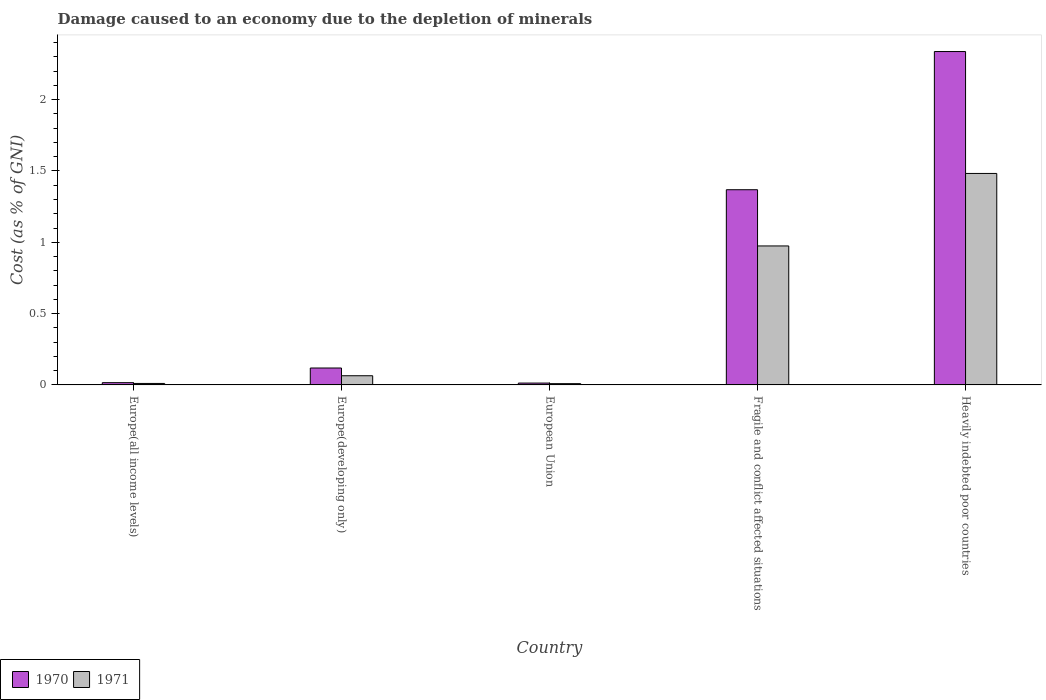How many different coloured bars are there?
Offer a very short reply. 2. How many groups of bars are there?
Make the answer very short. 5. Are the number of bars per tick equal to the number of legend labels?
Give a very brief answer. Yes. Are the number of bars on each tick of the X-axis equal?
Your answer should be very brief. Yes. What is the label of the 4th group of bars from the left?
Keep it short and to the point. Fragile and conflict affected situations. In how many cases, is the number of bars for a given country not equal to the number of legend labels?
Ensure brevity in your answer.  0. What is the cost of damage caused due to the depletion of minerals in 1971 in Europe(all income levels)?
Your answer should be very brief. 0.01. Across all countries, what is the maximum cost of damage caused due to the depletion of minerals in 1971?
Your answer should be very brief. 1.48. Across all countries, what is the minimum cost of damage caused due to the depletion of minerals in 1971?
Provide a succinct answer. 0.01. In which country was the cost of damage caused due to the depletion of minerals in 1971 maximum?
Offer a very short reply. Heavily indebted poor countries. What is the total cost of damage caused due to the depletion of minerals in 1971 in the graph?
Keep it short and to the point. 2.54. What is the difference between the cost of damage caused due to the depletion of minerals in 1971 in Europe(all income levels) and that in Fragile and conflict affected situations?
Provide a short and direct response. -0.96. What is the difference between the cost of damage caused due to the depletion of minerals in 1971 in Fragile and conflict affected situations and the cost of damage caused due to the depletion of minerals in 1970 in Europe(all income levels)?
Your answer should be very brief. 0.96. What is the average cost of damage caused due to the depletion of minerals in 1970 per country?
Give a very brief answer. 0.77. What is the difference between the cost of damage caused due to the depletion of minerals of/in 1971 and cost of damage caused due to the depletion of minerals of/in 1970 in Europe(developing only)?
Ensure brevity in your answer.  -0.05. In how many countries, is the cost of damage caused due to the depletion of minerals in 1971 greater than 1.9 %?
Ensure brevity in your answer.  0. What is the ratio of the cost of damage caused due to the depletion of minerals in 1971 in Europe(developing only) to that in Fragile and conflict affected situations?
Make the answer very short. 0.07. Is the cost of damage caused due to the depletion of minerals in 1971 in Europe(all income levels) less than that in Europe(developing only)?
Offer a very short reply. Yes. What is the difference between the highest and the second highest cost of damage caused due to the depletion of minerals in 1971?
Give a very brief answer. -0.51. What is the difference between the highest and the lowest cost of damage caused due to the depletion of minerals in 1971?
Your answer should be compact. 1.47. How many bars are there?
Give a very brief answer. 10. How many countries are there in the graph?
Your answer should be compact. 5. What is the difference between two consecutive major ticks on the Y-axis?
Offer a very short reply. 0.5. Does the graph contain any zero values?
Give a very brief answer. No. Does the graph contain grids?
Your answer should be very brief. No. Where does the legend appear in the graph?
Give a very brief answer. Bottom left. How are the legend labels stacked?
Give a very brief answer. Horizontal. What is the title of the graph?
Offer a very short reply. Damage caused to an economy due to the depletion of minerals. What is the label or title of the Y-axis?
Keep it short and to the point. Cost (as % of GNI). What is the Cost (as % of GNI) of 1970 in Europe(all income levels)?
Offer a very short reply. 0.02. What is the Cost (as % of GNI) of 1971 in Europe(all income levels)?
Provide a succinct answer. 0.01. What is the Cost (as % of GNI) in 1970 in Europe(developing only)?
Offer a very short reply. 0.12. What is the Cost (as % of GNI) in 1971 in Europe(developing only)?
Your answer should be compact. 0.06. What is the Cost (as % of GNI) of 1970 in European Union?
Your answer should be compact. 0.01. What is the Cost (as % of GNI) in 1971 in European Union?
Make the answer very short. 0.01. What is the Cost (as % of GNI) in 1970 in Fragile and conflict affected situations?
Ensure brevity in your answer.  1.37. What is the Cost (as % of GNI) in 1971 in Fragile and conflict affected situations?
Provide a short and direct response. 0.97. What is the Cost (as % of GNI) of 1970 in Heavily indebted poor countries?
Offer a very short reply. 2.34. What is the Cost (as % of GNI) in 1971 in Heavily indebted poor countries?
Make the answer very short. 1.48. Across all countries, what is the maximum Cost (as % of GNI) in 1970?
Keep it short and to the point. 2.34. Across all countries, what is the maximum Cost (as % of GNI) in 1971?
Provide a short and direct response. 1.48. Across all countries, what is the minimum Cost (as % of GNI) in 1970?
Provide a short and direct response. 0.01. Across all countries, what is the minimum Cost (as % of GNI) of 1971?
Your response must be concise. 0.01. What is the total Cost (as % of GNI) in 1970 in the graph?
Offer a very short reply. 3.85. What is the total Cost (as % of GNI) of 1971 in the graph?
Your answer should be compact. 2.54. What is the difference between the Cost (as % of GNI) of 1970 in Europe(all income levels) and that in Europe(developing only)?
Offer a very short reply. -0.1. What is the difference between the Cost (as % of GNI) of 1971 in Europe(all income levels) and that in Europe(developing only)?
Offer a terse response. -0.05. What is the difference between the Cost (as % of GNI) in 1970 in Europe(all income levels) and that in European Union?
Provide a succinct answer. 0. What is the difference between the Cost (as % of GNI) of 1971 in Europe(all income levels) and that in European Union?
Make the answer very short. 0. What is the difference between the Cost (as % of GNI) of 1970 in Europe(all income levels) and that in Fragile and conflict affected situations?
Make the answer very short. -1.35. What is the difference between the Cost (as % of GNI) in 1971 in Europe(all income levels) and that in Fragile and conflict affected situations?
Offer a terse response. -0.96. What is the difference between the Cost (as % of GNI) in 1970 in Europe(all income levels) and that in Heavily indebted poor countries?
Provide a succinct answer. -2.32. What is the difference between the Cost (as % of GNI) of 1971 in Europe(all income levels) and that in Heavily indebted poor countries?
Ensure brevity in your answer.  -1.47. What is the difference between the Cost (as % of GNI) of 1970 in Europe(developing only) and that in European Union?
Provide a succinct answer. 0.11. What is the difference between the Cost (as % of GNI) of 1971 in Europe(developing only) and that in European Union?
Provide a succinct answer. 0.06. What is the difference between the Cost (as % of GNI) in 1970 in Europe(developing only) and that in Fragile and conflict affected situations?
Provide a succinct answer. -1.25. What is the difference between the Cost (as % of GNI) of 1971 in Europe(developing only) and that in Fragile and conflict affected situations?
Your answer should be very brief. -0.91. What is the difference between the Cost (as % of GNI) of 1970 in Europe(developing only) and that in Heavily indebted poor countries?
Offer a terse response. -2.22. What is the difference between the Cost (as % of GNI) in 1971 in Europe(developing only) and that in Heavily indebted poor countries?
Your answer should be very brief. -1.42. What is the difference between the Cost (as % of GNI) of 1970 in European Union and that in Fragile and conflict affected situations?
Provide a succinct answer. -1.36. What is the difference between the Cost (as % of GNI) of 1971 in European Union and that in Fragile and conflict affected situations?
Offer a terse response. -0.97. What is the difference between the Cost (as % of GNI) in 1970 in European Union and that in Heavily indebted poor countries?
Your answer should be compact. -2.32. What is the difference between the Cost (as % of GNI) in 1971 in European Union and that in Heavily indebted poor countries?
Your response must be concise. -1.47. What is the difference between the Cost (as % of GNI) in 1970 in Fragile and conflict affected situations and that in Heavily indebted poor countries?
Your response must be concise. -0.97. What is the difference between the Cost (as % of GNI) of 1971 in Fragile and conflict affected situations and that in Heavily indebted poor countries?
Your answer should be compact. -0.51. What is the difference between the Cost (as % of GNI) of 1970 in Europe(all income levels) and the Cost (as % of GNI) of 1971 in Europe(developing only)?
Make the answer very short. -0.05. What is the difference between the Cost (as % of GNI) in 1970 in Europe(all income levels) and the Cost (as % of GNI) in 1971 in European Union?
Your answer should be very brief. 0.01. What is the difference between the Cost (as % of GNI) in 1970 in Europe(all income levels) and the Cost (as % of GNI) in 1971 in Fragile and conflict affected situations?
Provide a succinct answer. -0.96. What is the difference between the Cost (as % of GNI) in 1970 in Europe(all income levels) and the Cost (as % of GNI) in 1971 in Heavily indebted poor countries?
Provide a short and direct response. -1.47. What is the difference between the Cost (as % of GNI) in 1970 in Europe(developing only) and the Cost (as % of GNI) in 1971 in European Union?
Offer a very short reply. 0.11. What is the difference between the Cost (as % of GNI) in 1970 in Europe(developing only) and the Cost (as % of GNI) in 1971 in Fragile and conflict affected situations?
Your answer should be very brief. -0.86. What is the difference between the Cost (as % of GNI) in 1970 in Europe(developing only) and the Cost (as % of GNI) in 1971 in Heavily indebted poor countries?
Offer a very short reply. -1.36. What is the difference between the Cost (as % of GNI) in 1970 in European Union and the Cost (as % of GNI) in 1971 in Fragile and conflict affected situations?
Make the answer very short. -0.96. What is the difference between the Cost (as % of GNI) of 1970 in European Union and the Cost (as % of GNI) of 1971 in Heavily indebted poor countries?
Your answer should be compact. -1.47. What is the difference between the Cost (as % of GNI) in 1970 in Fragile and conflict affected situations and the Cost (as % of GNI) in 1971 in Heavily indebted poor countries?
Your response must be concise. -0.11. What is the average Cost (as % of GNI) in 1970 per country?
Offer a very short reply. 0.77. What is the average Cost (as % of GNI) in 1971 per country?
Offer a very short reply. 0.51. What is the difference between the Cost (as % of GNI) of 1970 and Cost (as % of GNI) of 1971 in Europe(all income levels)?
Provide a succinct answer. 0.01. What is the difference between the Cost (as % of GNI) in 1970 and Cost (as % of GNI) in 1971 in Europe(developing only)?
Your response must be concise. 0.05. What is the difference between the Cost (as % of GNI) of 1970 and Cost (as % of GNI) of 1971 in European Union?
Give a very brief answer. 0. What is the difference between the Cost (as % of GNI) of 1970 and Cost (as % of GNI) of 1971 in Fragile and conflict affected situations?
Your response must be concise. 0.39. What is the difference between the Cost (as % of GNI) of 1970 and Cost (as % of GNI) of 1971 in Heavily indebted poor countries?
Your answer should be very brief. 0.85. What is the ratio of the Cost (as % of GNI) of 1970 in Europe(all income levels) to that in Europe(developing only)?
Provide a short and direct response. 0.13. What is the ratio of the Cost (as % of GNI) of 1971 in Europe(all income levels) to that in Europe(developing only)?
Ensure brevity in your answer.  0.16. What is the ratio of the Cost (as % of GNI) in 1970 in Europe(all income levels) to that in European Union?
Offer a very short reply. 1.22. What is the ratio of the Cost (as % of GNI) in 1971 in Europe(all income levels) to that in European Union?
Your response must be concise. 1.16. What is the ratio of the Cost (as % of GNI) of 1970 in Europe(all income levels) to that in Fragile and conflict affected situations?
Offer a very short reply. 0.01. What is the ratio of the Cost (as % of GNI) of 1971 in Europe(all income levels) to that in Fragile and conflict affected situations?
Ensure brevity in your answer.  0.01. What is the ratio of the Cost (as % of GNI) in 1970 in Europe(all income levels) to that in Heavily indebted poor countries?
Offer a terse response. 0.01. What is the ratio of the Cost (as % of GNI) of 1971 in Europe(all income levels) to that in Heavily indebted poor countries?
Provide a succinct answer. 0.01. What is the ratio of the Cost (as % of GNI) of 1970 in Europe(developing only) to that in European Union?
Keep it short and to the point. 9.17. What is the ratio of the Cost (as % of GNI) in 1971 in Europe(developing only) to that in European Union?
Your answer should be very brief. 7.27. What is the ratio of the Cost (as % of GNI) in 1970 in Europe(developing only) to that in Fragile and conflict affected situations?
Ensure brevity in your answer.  0.09. What is the ratio of the Cost (as % of GNI) in 1971 in Europe(developing only) to that in Fragile and conflict affected situations?
Provide a succinct answer. 0.07. What is the ratio of the Cost (as % of GNI) of 1970 in Europe(developing only) to that in Heavily indebted poor countries?
Your answer should be compact. 0.05. What is the ratio of the Cost (as % of GNI) of 1971 in Europe(developing only) to that in Heavily indebted poor countries?
Provide a succinct answer. 0.04. What is the ratio of the Cost (as % of GNI) of 1970 in European Union to that in Fragile and conflict affected situations?
Offer a terse response. 0.01. What is the ratio of the Cost (as % of GNI) in 1971 in European Union to that in Fragile and conflict affected situations?
Your response must be concise. 0.01. What is the ratio of the Cost (as % of GNI) of 1970 in European Union to that in Heavily indebted poor countries?
Offer a very short reply. 0.01. What is the ratio of the Cost (as % of GNI) of 1971 in European Union to that in Heavily indebted poor countries?
Your answer should be very brief. 0.01. What is the ratio of the Cost (as % of GNI) in 1970 in Fragile and conflict affected situations to that in Heavily indebted poor countries?
Give a very brief answer. 0.59. What is the ratio of the Cost (as % of GNI) of 1971 in Fragile and conflict affected situations to that in Heavily indebted poor countries?
Ensure brevity in your answer.  0.66. What is the difference between the highest and the second highest Cost (as % of GNI) in 1970?
Provide a succinct answer. 0.97. What is the difference between the highest and the second highest Cost (as % of GNI) of 1971?
Keep it short and to the point. 0.51. What is the difference between the highest and the lowest Cost (as % of GNI) of 1970?
Give a very brief answer. 2.32. What is the difference between the highest and the lowest Cost (as % of GNI) of 1971?
Your answer should be compact. 1.47. 